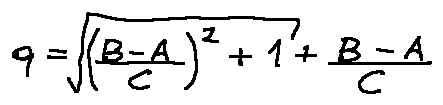<formula> <loc_0><loc_0><loc_500><loc_500>q = \sqrt { ( \frac { B - A } { C } ) ^ { 2 } + 1 } + \frac { B - A } { C }</formula> 